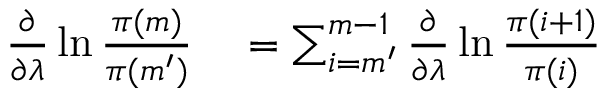Convert formula to latex. <formula><loc_0><loc_0><loc_500><loc_500>\begin{array} { r l } { \frac { \partial } { \partial \lambda } \ln \frac { \pi ( m ) } { \pi ( m ^ { \prime } ) } } & = \sum _ { i = m ^ { \prime } } ^ { m - 1 } \frac { \partial } { \partial \lambda } \ln \frac { \pi ( i + 1 ) } { \pi ( i ) } } \end{array}</formula> 